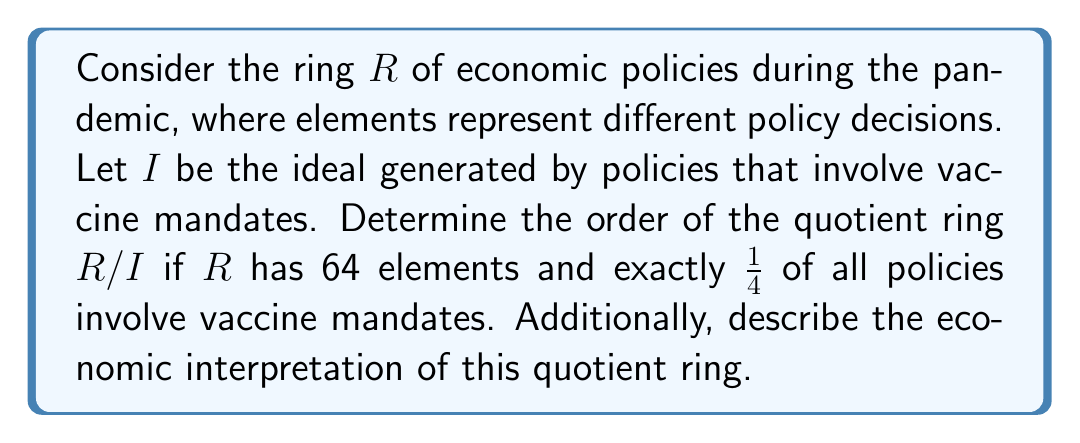Could you help me with this problem? To solve this problem, we need to follow these steps:

1) First, we need to understand what the quotient ring $R/I$ represents in this context. The ring $R$ contains all possible economic policies during the pandemic, and the ideal $I$ consists of all policies involving vaccine mandates. The quotient ring $R/I$ thus represents the set of policy decisions modulo vaccine mandates, or in other words, the set of policies considered equivalent if we disregard their stance on vaccine mandates.

2) We're given that $R$ has 64 elements, which means there are 64 distinct economic policies in total.

3) We're also told that exactly 1/4 of all policies involve vaccine mandates. This means:

   Number of policies involving vaccine mandates = $\frac{1}{4} \times 64 = 16$

4) In ring theory, the order of a quotient ring $R/I$ is equal to the number of cosets of $I$ in $R$. This is equivalent to the number of elements in $R$ that are not in $I$. Therefore:

   $|R/I| = |R| - |I| = 64 - 16 = 48$

5) Economically, this quotient ring represents the space of policy decisions when we consider policies equivalent if they differ only in their approach to vaccine mandates. The order of 48 indicates that there are 48 distinct policy approaches when vaccine mandate differences are disregarded.

This result aligns with the skepticism towards vaccine-related policies, as it shows how focusing on other aspects of pandemic response yields a smaller, potentially more manageable set of policy options.
Answer: The order of the quotient ring $R/I$ is 48. Economically, this represents the number of distinct policy approaches when differences in vaccine mandate policies are disregarded. 